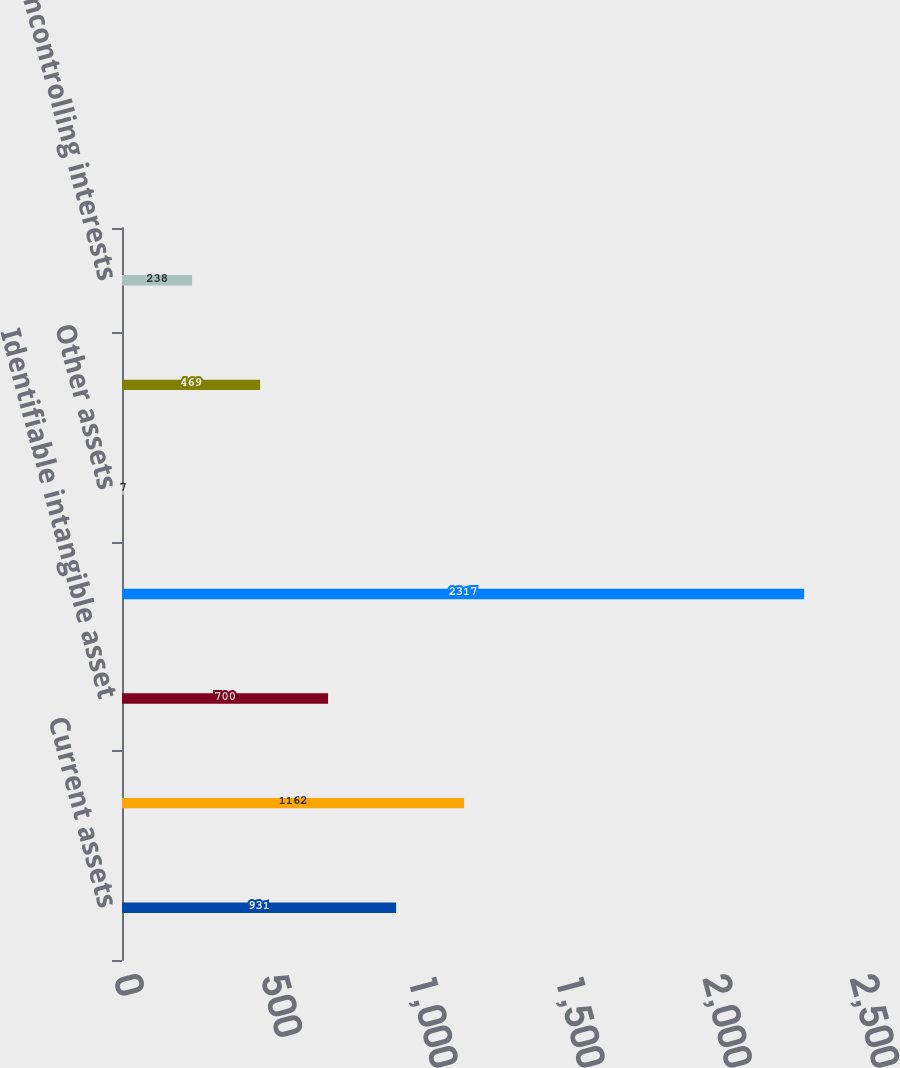Convert chart to OTSL. <chart><loc_0><loc_0><loc_500><loc_500><bar_chart><fcel>Current assets<fcel>Property and equipment<fcel>Identifiable intangible asset<fcel>Goodwill<fcel>Other assets<fcel>Liabilities<fcel>Noncontrolling interests<nl><fcel>931<fcel>1162<fcel>700<fcel>2317<fcel>7<fcel>469<fcel>238<nl></chart> 